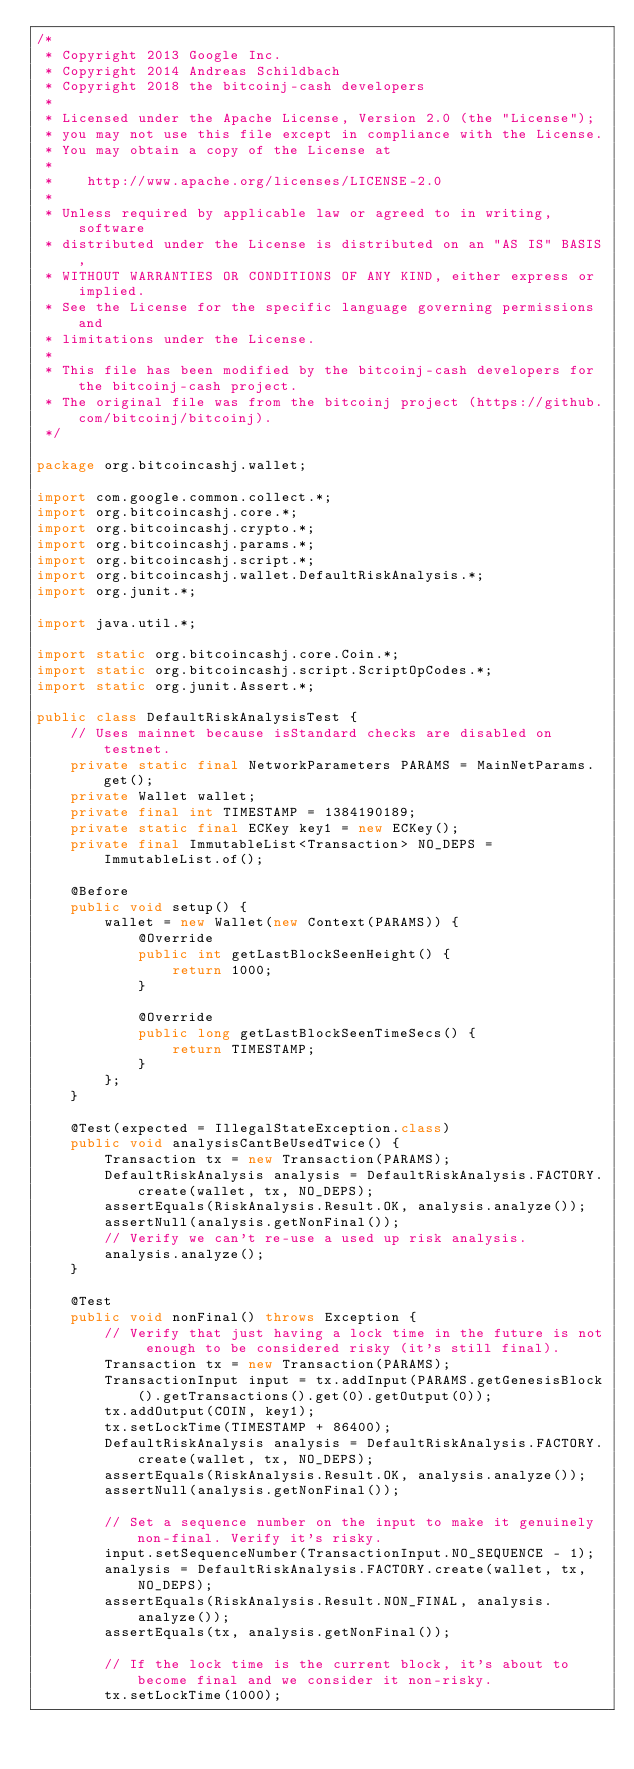Convert code to text. <code><loc_0><loc_0><loc_500><loc_500><_Java_>/*
 * Copyright 2013 Google Inc.
 * Copyright 2014 Andreas Schildbach
 * Copyright 2018 the bitcoinj-cash developers
 *
 * Licensed under the Apache License, Version 2.0 (the "License");
 * you may not use this file except in compliance with the License.
 * You may obtain a copy of the License at
 *
 *    http://www.apache.org/licenses/LICENSE-2.0
 *
 * Unless required by applicable law or agreed to in writing, software
 * distributed under the License is distributed on an "AS IS" BASIS,
 * WITHOUT WARRANTIES OR CONDITIONS OF ANY KIND, either express or implied.
 * See the License for the specific language governing permissions and
 * limitations under the License.
 *
 * This file has been modified by the bitcoinj-cash developers for the bitcoinj-cash project.
 * The original file was from the bitcoinj project (https://github.com/bitcoinj/bitcoinj).
 */

package org.bitcoincashj.wallet;

import com.google.common.collect.*;
import org.bitcoincashj.core.*;
import org.bitcoincashj.crypto.*;
import org.bitcoincashj.params.*;
import org.bitcoincashj.script.*;
import org.bitcoincashj.wallet.DefaultRiskAnalysis.*;
import org.junit.*;

import java.util.*;

import static org.bitcoincashj.core.Coin.*;
import static org.bitcoincashj.script.ScriptOpCodes.*;
import static org.junit.Assert.*;

public class DefaultRiskAnalysisTest {
    // Uses mainnet because isStandard checks are disabled on testnet.
    private static final NetworkParameters PARAMS = MainNetParams.get();
    private Wallet wallet;
    private final int TIMESTAMP = 1384190189;
    private static final ECKey key1 = new ECKey();
    private final ImmutableList<Transaction> NO_DEPS = ImmutableList.of();

    @Before
    public void setup() {
        wallet = new Wallet(new Context(PARAMS)) {
            @Override
            public int getLastBlockSeenHeight() {
                return 1000;
            }

            @Override
            public long getLastBlockSeenTimeSecs() {
                return TIMESTAMP;
            }
        };
    }

    @Test(expected = IllegalStateException.class)
    public void analysisCantBeUsedTwice() {
        Transaction tx = new Transaction(PARAMS);
        DefaultRiskAnalysis analysis = DefaultRiskAnalysis.FACTORY.create(wallet, tx, NO_DEPS);
        assertEquals(RiskAnalysis.Result.OK, analysis.analyze());
        assertNull(analysis.getNonFinal());
        // Verify we can't re-use a used up risk analysis.
        analysis.analyze();
    }

    @Test
    public void nonFinal() throws Exception {
        // Verify that just having a lock time in the future is not enough to be considered risky (it's still final).
        Transaction tx = new Transaction(PARAMS);
        TransactionInput input = tx.addInput(PARAMS.getGenesisBlock().getTransactions().get(0).getOutput(0));
        tx.addOutput(COIN, key1);
        tx.setLockTime(TIMESTAMP + 86400);
        DefaultRiskAnalysis analysis = DefaultRiskAnalysis.FACTORY.create(wallet, tx, NO_DEPS);
        assertEquals(RiskAnalysis.Result.OK, analysis.analyze());
        assertNull(analysis.getNonFinal());

        // Set a sequence number on the input to make it genuinely non-final. Verify it's risky.
        input.setSequenceNumber(TransactionInput.NO_SEQUENCE - 1);
        analysis = DefaultRiskAnalysis.FACTORY.create(wallet, tx, NO_DEPS);
        assertEquals(RiskAnalysis.Result.NON_FINAL, analysis.analyze());
        assertEquals(tx, analysis.getNonFinal());

        // If the lock time is the current block, it's about to become final and we consider it non-risky.
        tx.setLockTime(1000);</code> 